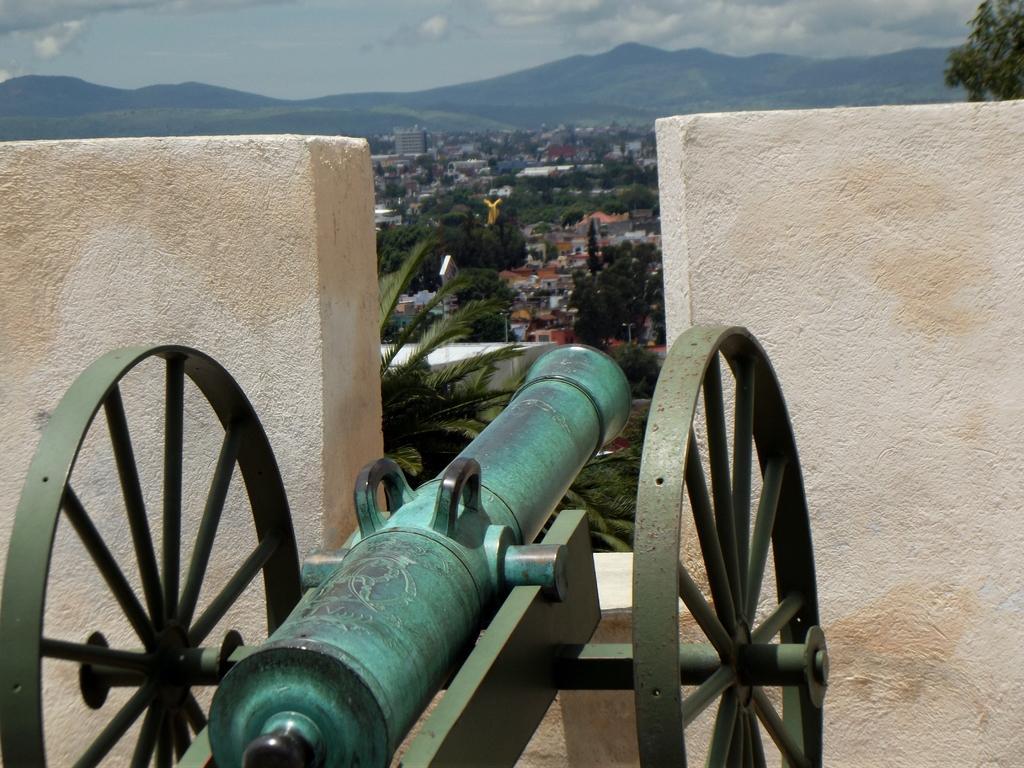Describe this image in one or two sentences. In this picture we can see a canon. A wall is visible from left to right. There are few trees, buildings and mountains in the background. Sky is cloudy. 